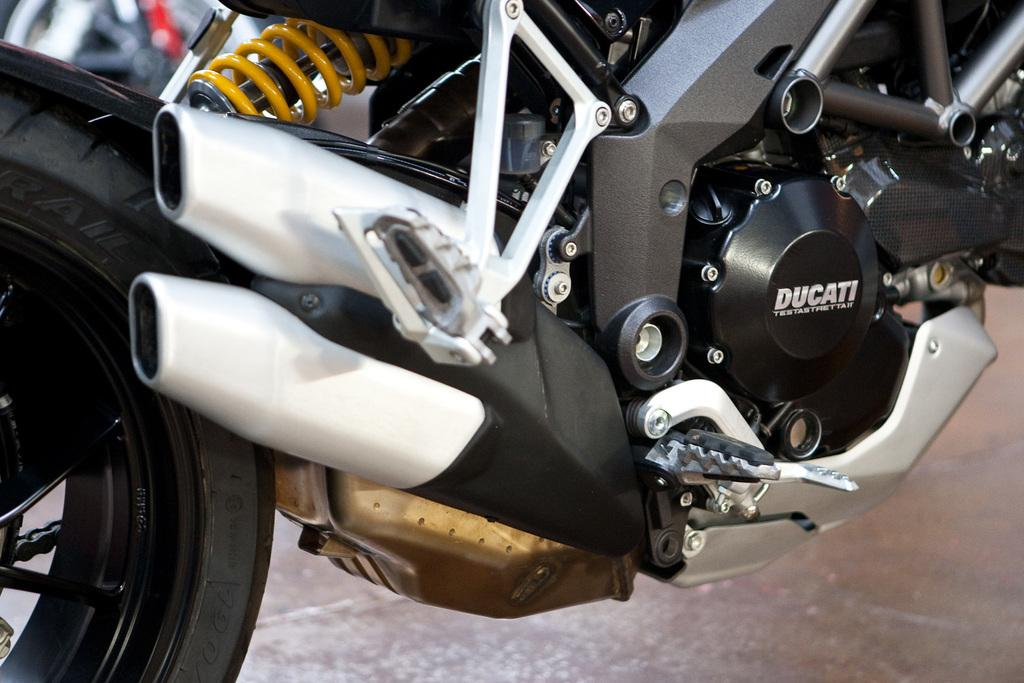What is the main subject of the picture? The main subject of the picture is a part of a motorbike. Can you describe the background of the image? The background of the image is blurred. How many dimes are visible on the motorbike in the image? There are no dimes visible on the motorbike in the image. What type of profit can be seen being made from the motorbike in the image? There is no indication of profit being made from the motorbike in the image. 